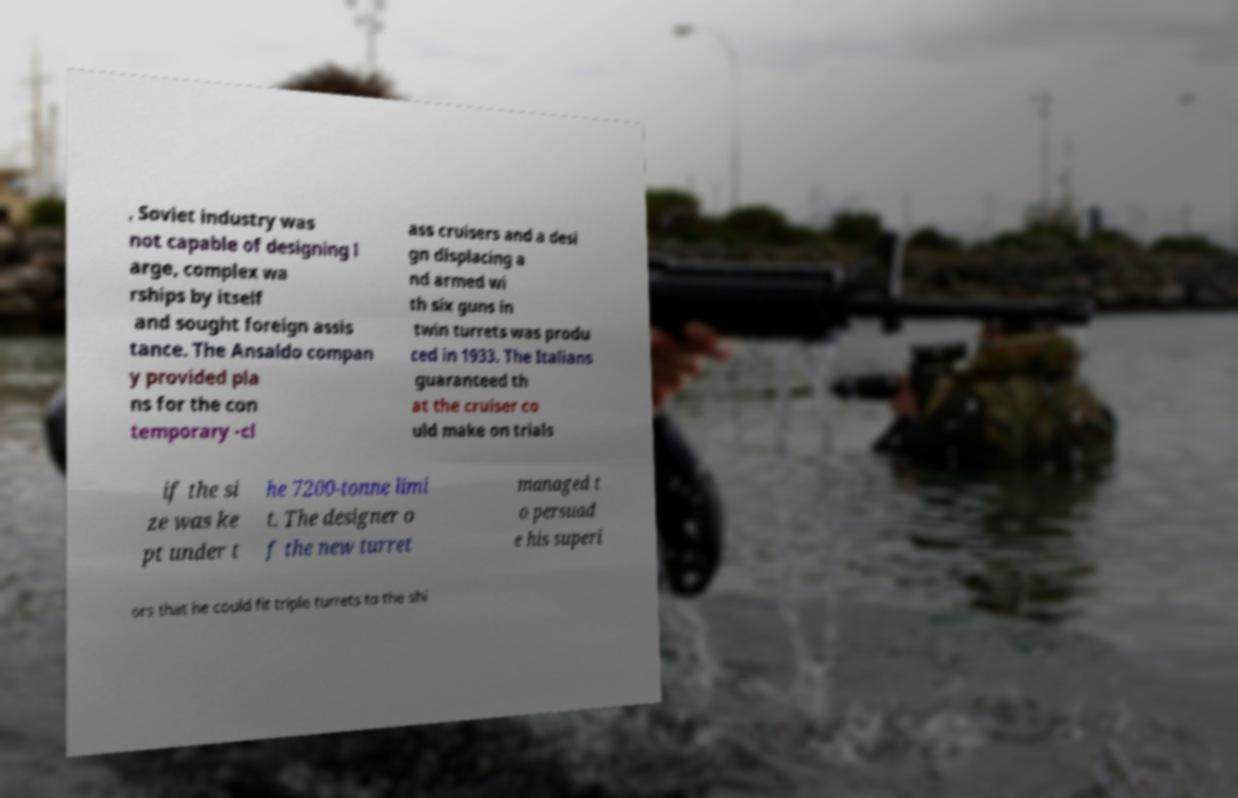Could you extract and type out the text from this image? , Soviet industry was not capable of designing l arge, complex wa rships by itself and sought foreign assis tance. The Ansaldo compan y provided pla ns for the con temporary -cl ass cruisers and a desi gn displacing a nd armed wi th six guns in twin turrets was produ ced in 1933. The Italians guaranteed th at the cruiser co uld make on trials if the si ze was ke pt under t he 7200-tonne limi t. The designer o f the new turret managed t o persuad e his superi ors that he could fit triple turrets to the shi 